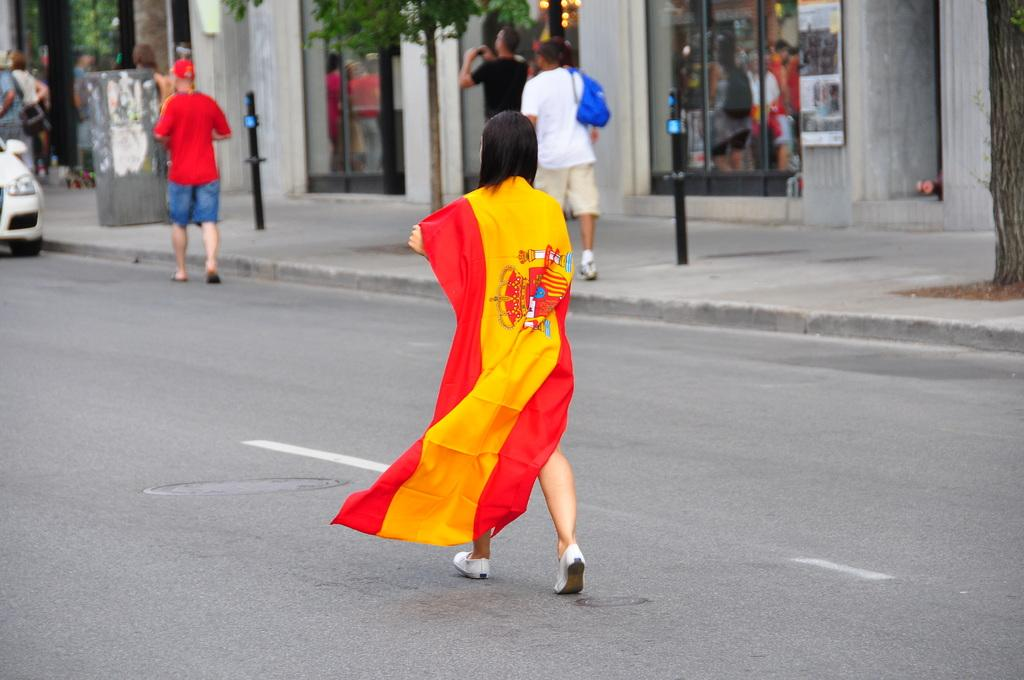What is located in the foreground of the image? There is a group of people and a car on the road in the foreground of the image. What can be seen in the background of the image? There is a building, trees, and a crowd in the background of the image. What time of day was the image taken? The image was taken during the day. What rate of speed is the car traveling at in the image? The rate of speed of the car cannot be determined from the image. What type of thrill can be experienced by the people in the crowd in the image? There is no indication of any thrilling activity in the image; it simply shows a group of people and a car on the road. 